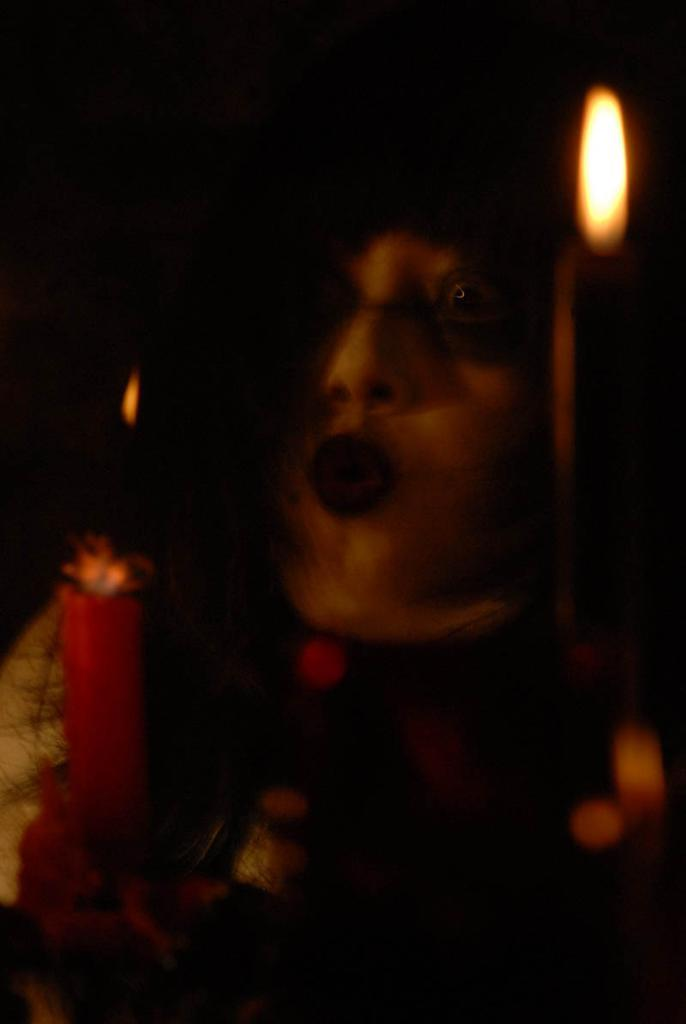What is the main subject of the image? There is a person in the image. What is the person holding in the image? The person is holding a candle. Can you describe the lighting in the image? There is a light on the right side of the image. How many friends are visible in the image? There are no friends visible in the image; it only features a person holding a candle. What type of cap is the person wearing in the image? There is no cap present in the image; the person is not wearing any headgear. 